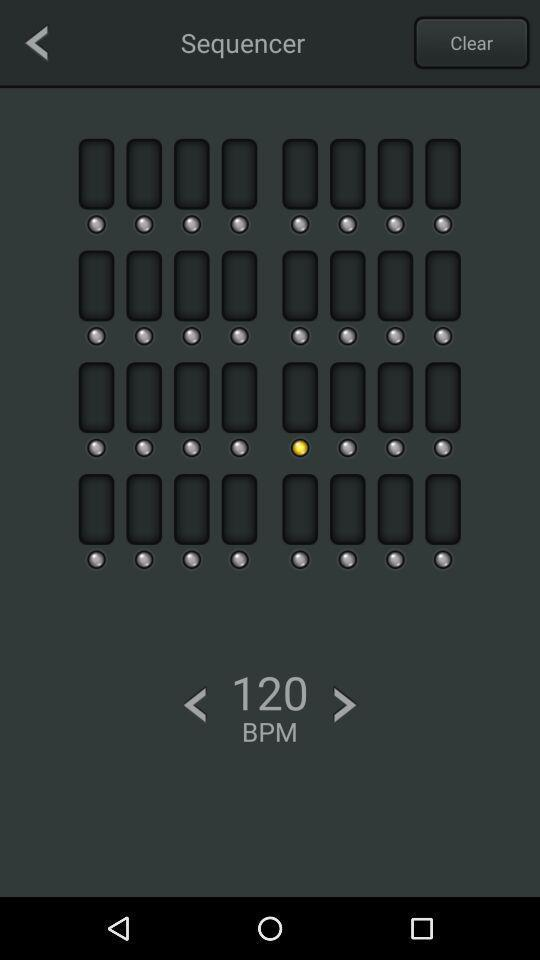What is the selected BPM? The selected BPM is 120. 